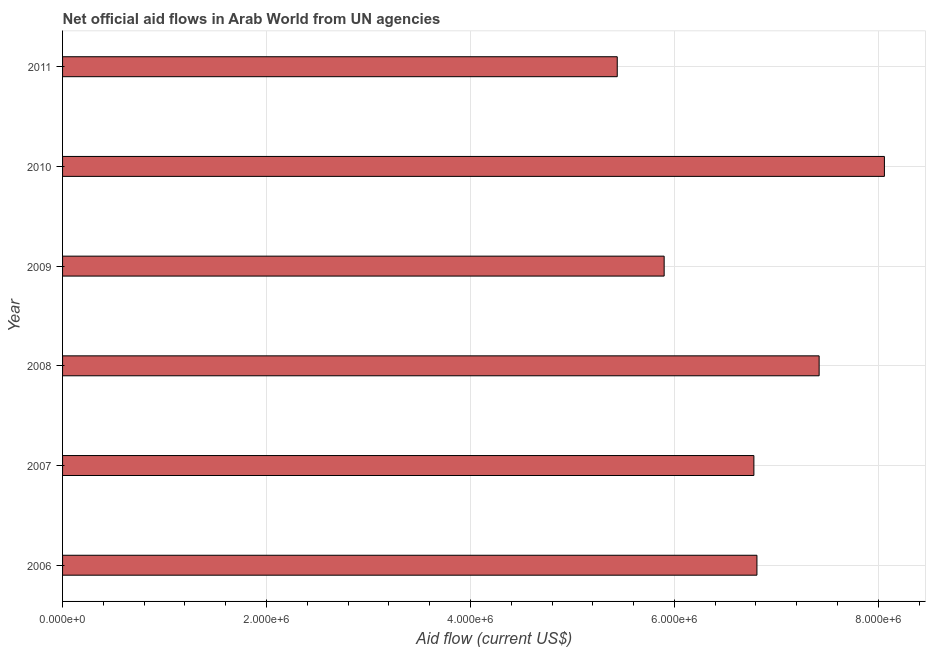What is the title of the graph?
Offer a very short reply. Net official aid flows in Arab World from UN agencies. What is the label or title of the X-axis?
Provide a short and direct response. Aid flow (current US$). What is the net official flows from un agencies in 2011?
Offer a terse response. 5.44e+06. Across all years, what is the maximum net official flows from un agencies?
Your answer should be compact. 8.06e+06. Across all years, what is the minimum net official flows from un agencies?
Your answer should be very brief. 5.44e+06. In which year was the net official flows from un agencies maximum?
Provide a short and direct response. 2010. What is the sum of the net official flows from un agencies?
Make the answer very short. 4.04e+07. What is the difference between the net official flows from un agencies in 2007 and 2008?
Offer a very short reply. -6.40e+05. What is the average net official flows from un agencies per year?
Provide a succinct answer. 6.74e+06. What is the median net official flows from un agencies?
Give a very brief answer. 6.80e+06. Do a majority of the years between 2008 and 2006 (inclusive) have net official flows from un agencies greater than 4800000 US$?
Provide a short and direct response. Yes. What is the ratio of the net official flows from un agencies in 2007 to that in 2010?
Make the answer very short. 0.84. What is the difference between the highest and the second highest net official flows from un agencies?
Your answer should be very brief. 6.40e+05. What is the difference between the highest and the lowest net official flows from un agencies?
Keep it short and to the point. 2.62e+06. What is the Aid flow (current US$) of 2006?
Your answer should be compact. 6.81e+06. What is the Aid flow (current US$) in 2007?
Provide a short and direct response. 6.78e+06. What is the Aid flow (current US$) of 2008?
Make the answer very short. 7.42e+06. What is the Aid flow (current US$) of 2009?
Your answer should be compact. 5.90e+06. What is the Aid flow (current US$) in 2010?
Your answer should be very brief. 8.06e+06. What is the Aid flow (current US$) in 2011?
Ensure brevity in your answer.  5.44e+06. What is the difference between the Aid flow (current US$) in 2006 and 2008?
Provide a short and direct response. -6.10e+05. What is the difference between the Aid flow (current US$) in 2006 and 2009?
Your response must be concise. 9.10e+05. What is the difference between the Aid flow (current US$) in 2006 and 2010?
Provide a short and direct response. -1.25e+06. What is the difference between the Aid flow (current US$) in 2006 and 2011?
Your response must be concise. 1.37e+06. What is the difference between the Aid flow (current US$) in 2007 and 2008?
Your response must be concise. -6.40e+05. What is the difference between the Aid flow (current US$) in 2007 and 2009?
Provide a short and direct response. 8.80e+05. What is the difference between the Aid flow (current US$) in 2007 and 2010?
Provide a succinct answer. -1.28e+06. What is the difference between the Aid flow (current US$) in 2007 and 2011?
Make the answer very short. 1.34e+06. What is the difference between the Aid flow (current US$) in 2008 and 2009?
Provide a succinct answer. 1.52e+06. What is the difference between the Aid flow (current US$) in 2008 and 2010?
Make the answer very short. -6.40e+05. What is the difference between the Aid flow (current US$) in 2008 and 2011?
Provide a succinct answer. 1.98e+06. What is the difference between the Aid flow (current US$) in 2009 and 2010?
Offer a terse response. -2.16e+06. What is the difference between the Aid flow (current US$) in 2010 and 2011?
Provide a succinct answer. 2.62e+06. What is the ratio of the Aid flow (current US$) in 2006 to that in 2007?
Provide a succinct answer. 1. What is the ratio of the Aid flow (current US$) in 2006 to that in 2008?
Provide a short and direct response. 0.92. What is the ratio of the Aid flow (current US$) in 2006 to that in 2009?
Make the answer very short. 1.15. What is the ratio of the Aid flow (current US$) in 2006 to that in 2010?
Your answer should be compact. 0.84. What is the ratio of the Aid flow (current US$) in 2006 to that in 2011?
Your answer should be compact. 1.25. What is the ratio of the Aid flow (current US$) in 2007 to that in 2008?
Make the answer very short. 0.91. What is the ratio of the Aid flow (current US$) in 2007 to that in 2009?
Your answer should be very brief. 1.15. What is the ratio of the Aid flow (current US$) in 2007 to that in 2010?
Your response must be concise. 0.84. What is the ratio of the Aid flow (current US$) in 2007 to that in 2011?
Keep it short and to the point. 1.25. What is the ratio of the Aid flow (current US$) in 2008 to that in 2009?
Provide a succinct answer. 1.26. What is the ratio of the Aid flow (current US$) in 2008 to that in 2010?
Your answer should be compact. 0.92. What is the ratio of the Aid flow (current US$) in 2008 to that in 2011?
Provide a succinct answer. 1.36. What is the ratio of the Aid flow (current US$) in 2009 to that in 2010?
Your answer should be very brief. 0.73. What is the ratio of the Aid flow (current US$) in 2009 to that in 2011?
Provide a short and direct response. 1.08. What is the ratio of the Aid flow (current US$) in 2010 to that in 2011?
Provide a short and direct response. 1.48. 